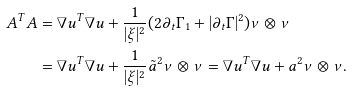<formula> <loc_0><loc_0><loc_500><loc_500>A ^ { T } A & = \nabla u ^ { T } \nabla u + \frac { 1 } { | \xi | ^ { 2 } } ( 2 \partial _ { t } \Gamma _ { 1 } + | \partial _ { t } \Gamma | ^ { 2 } ) \nu \otimes \nu \\ & = \nabla u ^ { T } \nabla u + \frac { 1 } { | \xi | ^ { 2 } } \tilde { a } ^ { 2 } \nu \otimes \nu = \nabla u ^ { T } \nabla u + a ^ { 2 } \nu \otimes \nu .</formula> 